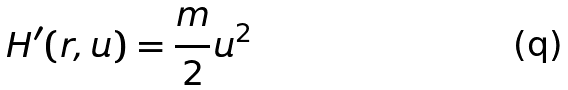<formula> <loc_0><loc_0><loc_500><loc_500>H ^ { \prime } ( r , u ) = \frac { m } { 2 } u ^ { 2 }</formula> 